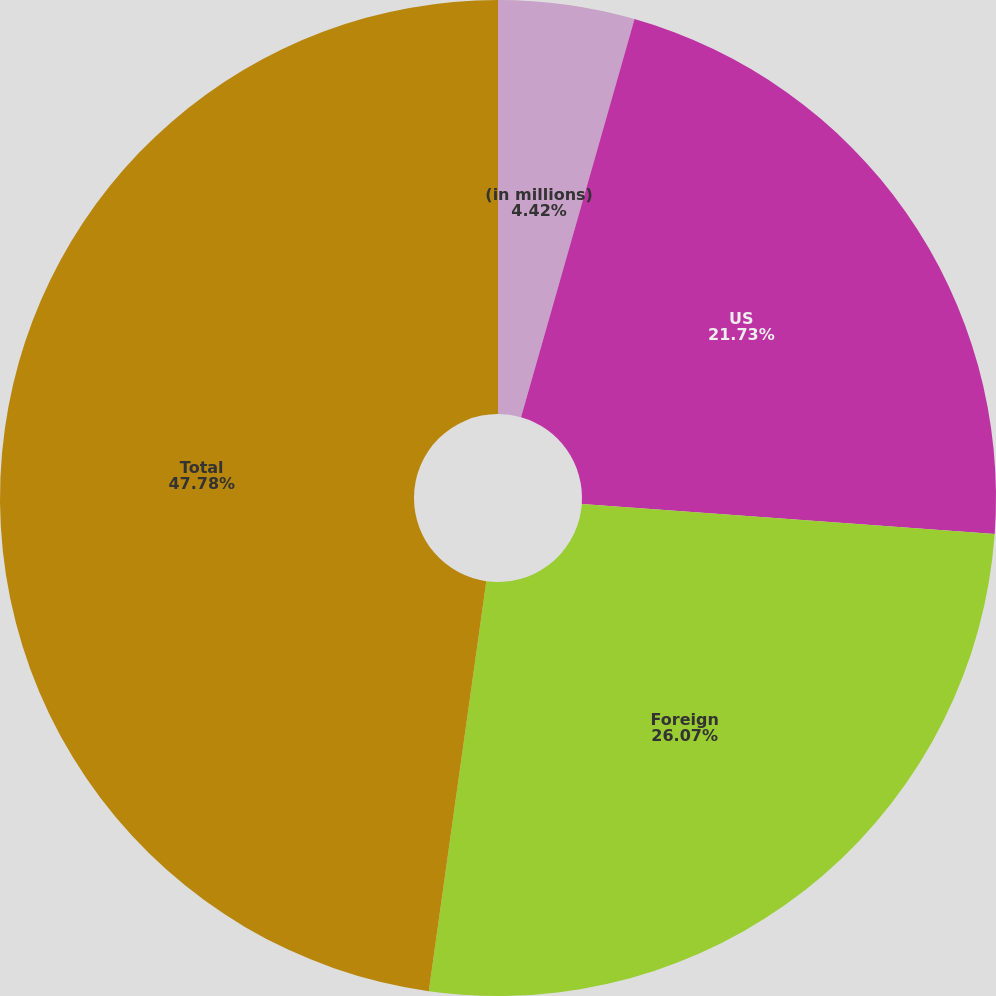Convert chart. <chart><loc_0><loc_0><loc_500><loc_500><pie_chart><fcel>(in millions)<fcel>US<fcel>Foreign<fcel>Total<nl><fcel>4.42%<fcel>21.73%<fcel>26.07%<fcel>47.78%<nl></chart> 